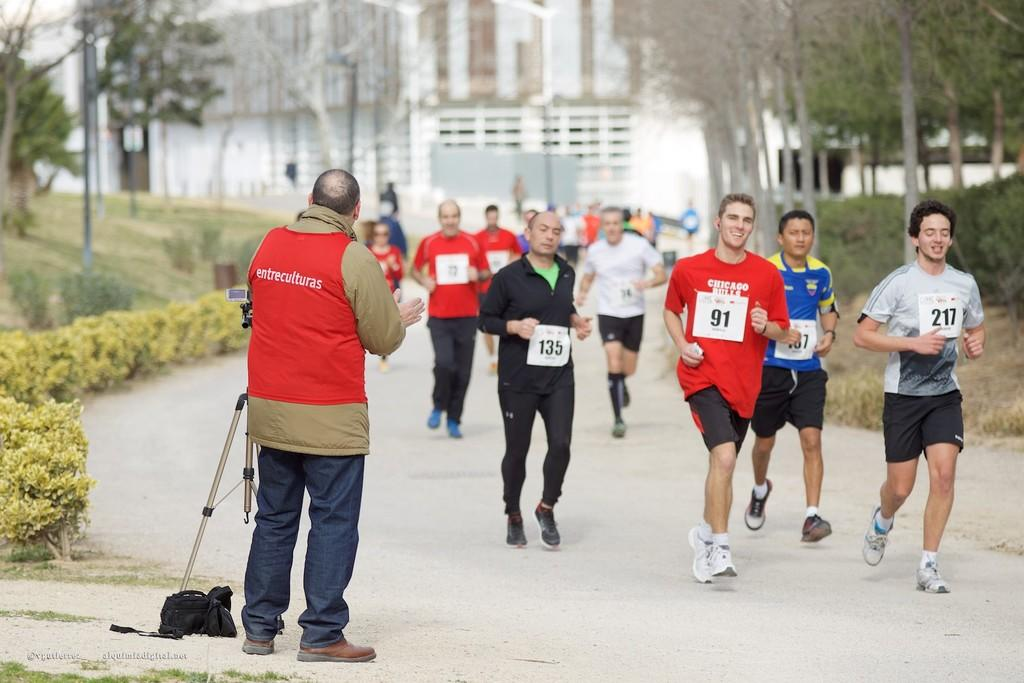What are the people in the image doing? The people in the image are running. What event are the people participating in? The people are participating in a marathon. What is the cameraman doing in the image? The cameraman is standing and taking photos. What can be seen in the background of the image? Trees and buildings are visible in the background of the image. How many dimes can be seen on the ground in the image? There are no dimes visible in the image. What type of plant is growing near the finish line in the image? There is no plant growing near the finish line in the image. 